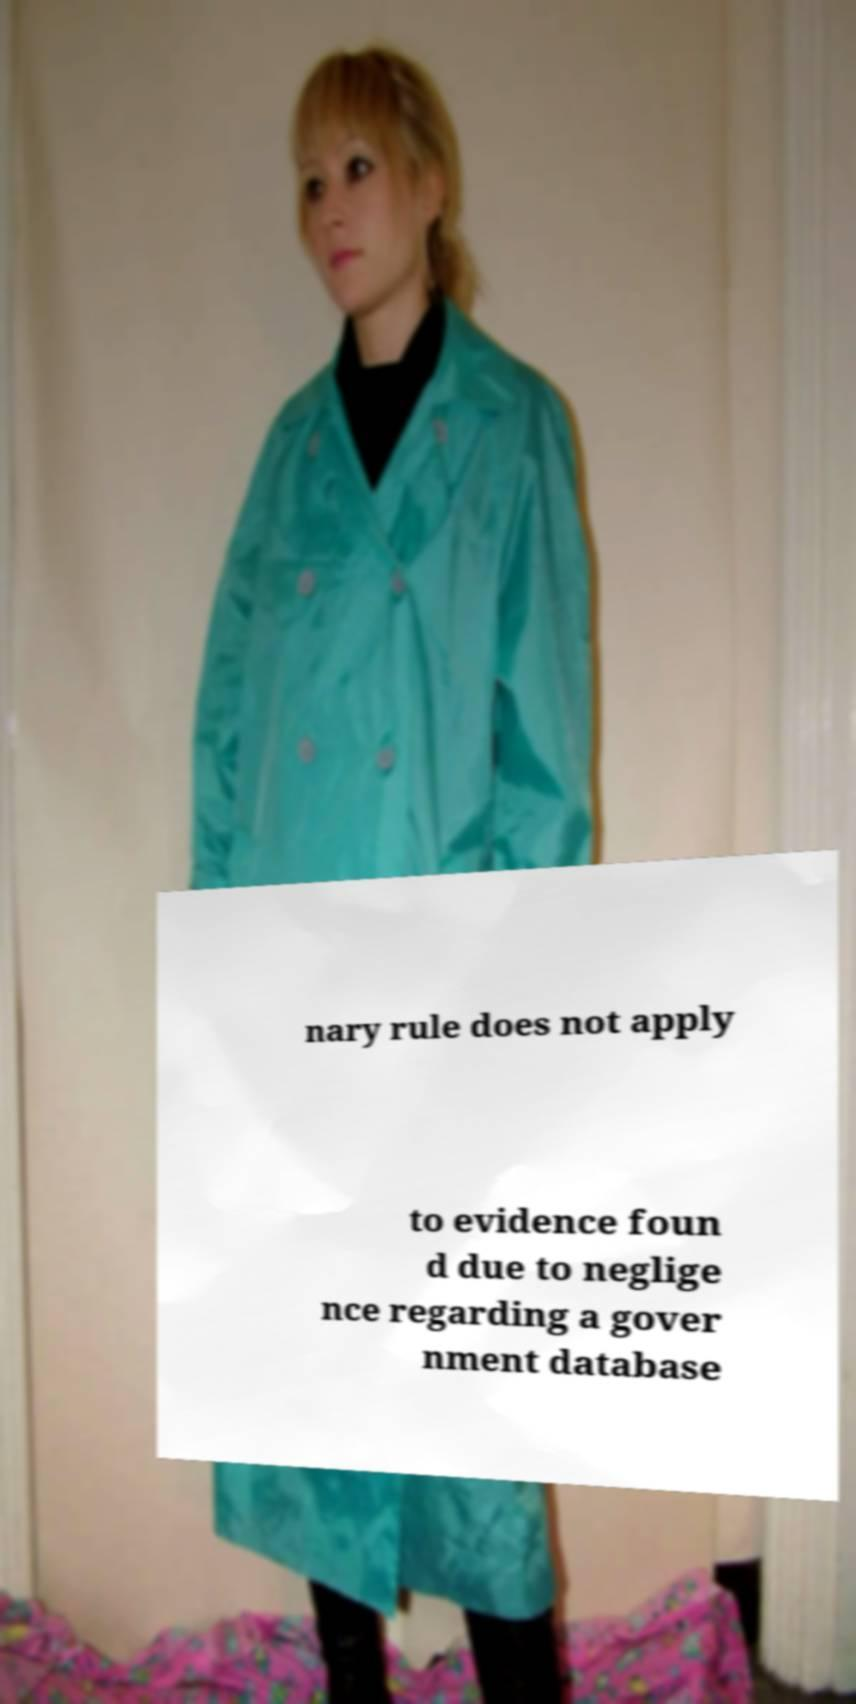Could you assist in decoding the text presented in this image and type it out clearly? nary rule does not apply to evidence foun d due to neglige nce regarding a gover nment database 